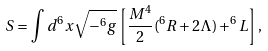Convert formula to latex. <formula><loc_0><loc_0><loc_500><loc_500>S = \int d ^ { 6 } x \sqrt { - ^ { 6 } g } \left [ \frac { M ^ { 4 } } { 2 } ( ^ { 6 } R + 2 \Lambda ) + ^ { 6 } L \right ] ,</formula> 